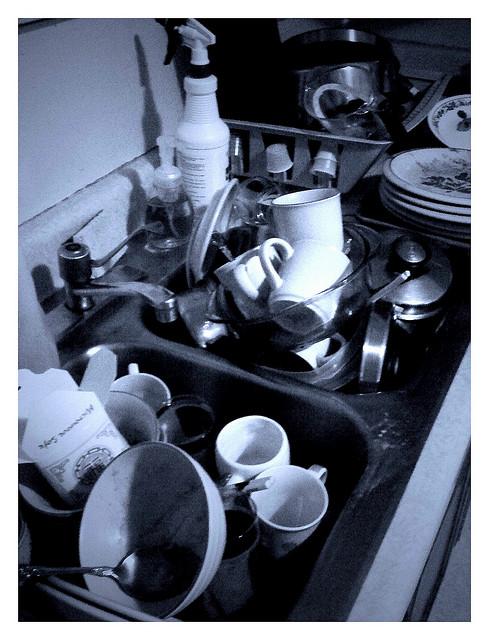Has anyone done the dishes lately?
Concise answer only. No. Is the a colorful picture?
Write a very short answer. No. Is there dish soap on the sink?
Short answer required. No. 